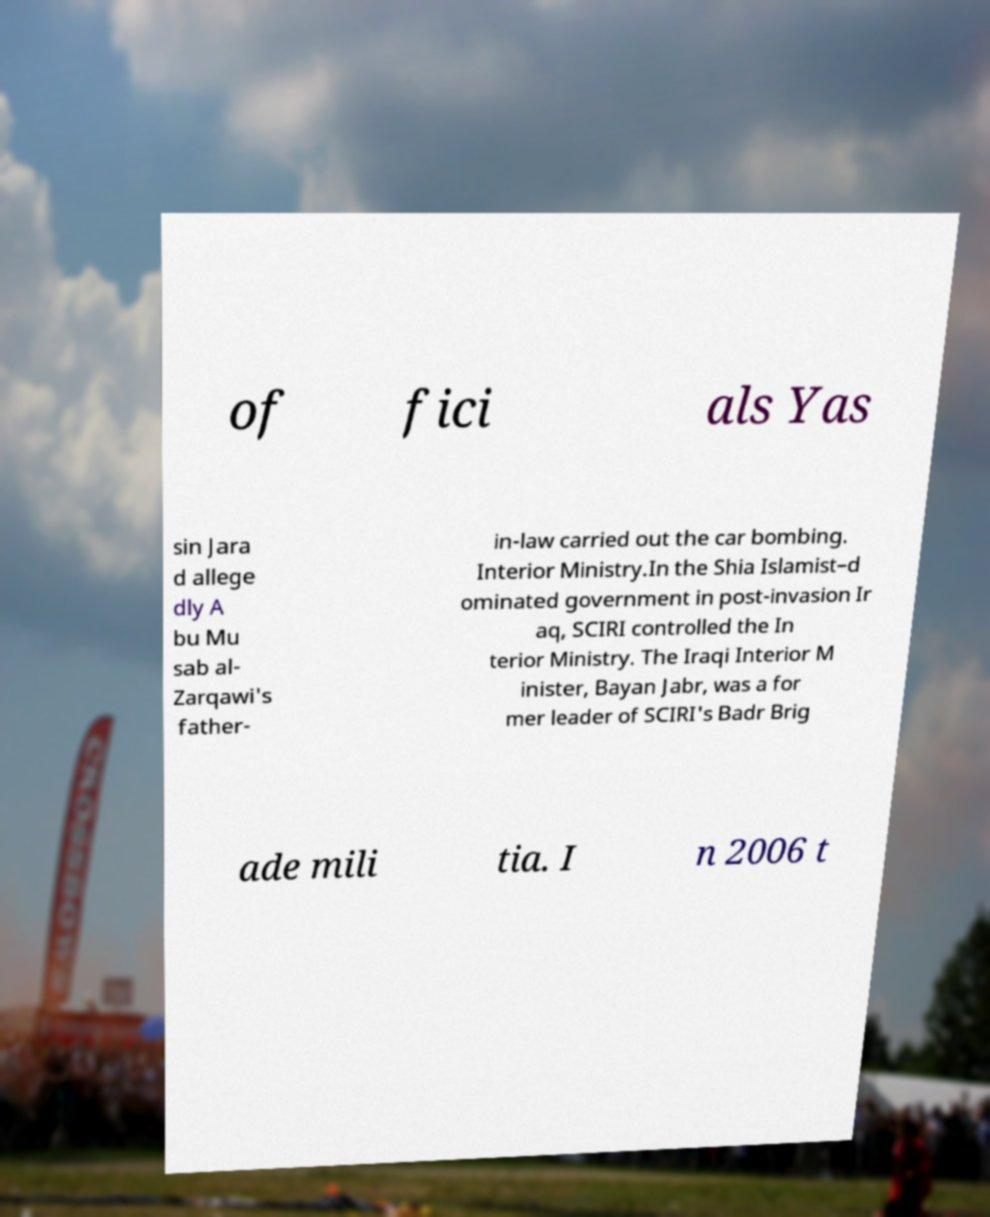Please read and relay the text visible in this image. What does it say? of fici als Yas sin Jara d allege dly A bu Mu sab al- Zarqawi's father- in-law carried out the car bombing. Interior Ministry.In the Shia Islamist–d ominated government in post-invasion Ir aq, SCIRI controlled the In terior Ministry. The Iraqi Interior M inister, Bayan Jabr, was a for mer leader of SCIRI's Badr Brig ade mili tia. I n 2006 t 